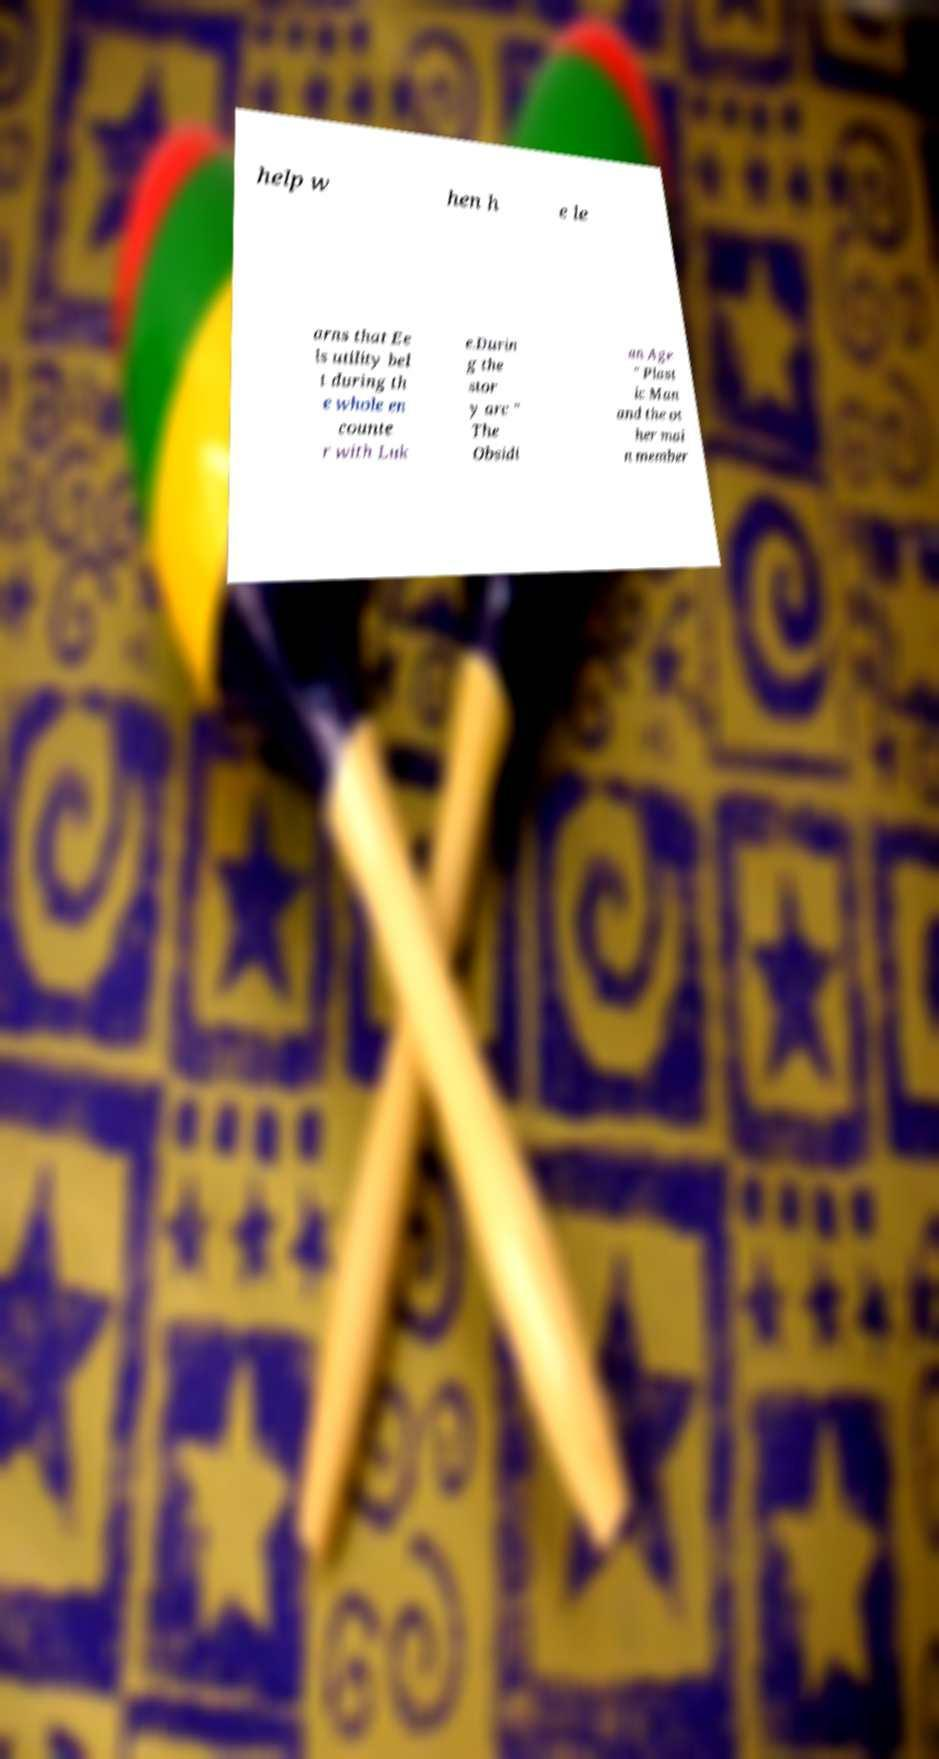I need the written content from this picture converted into text. Can you do that? help w hen h e le arns that Ee ls utility bel t during th e whole en counte r with Luk e.Durin g the stor y arc " The Obsidi an Age " Plast ic Man and the ot her mai n member 